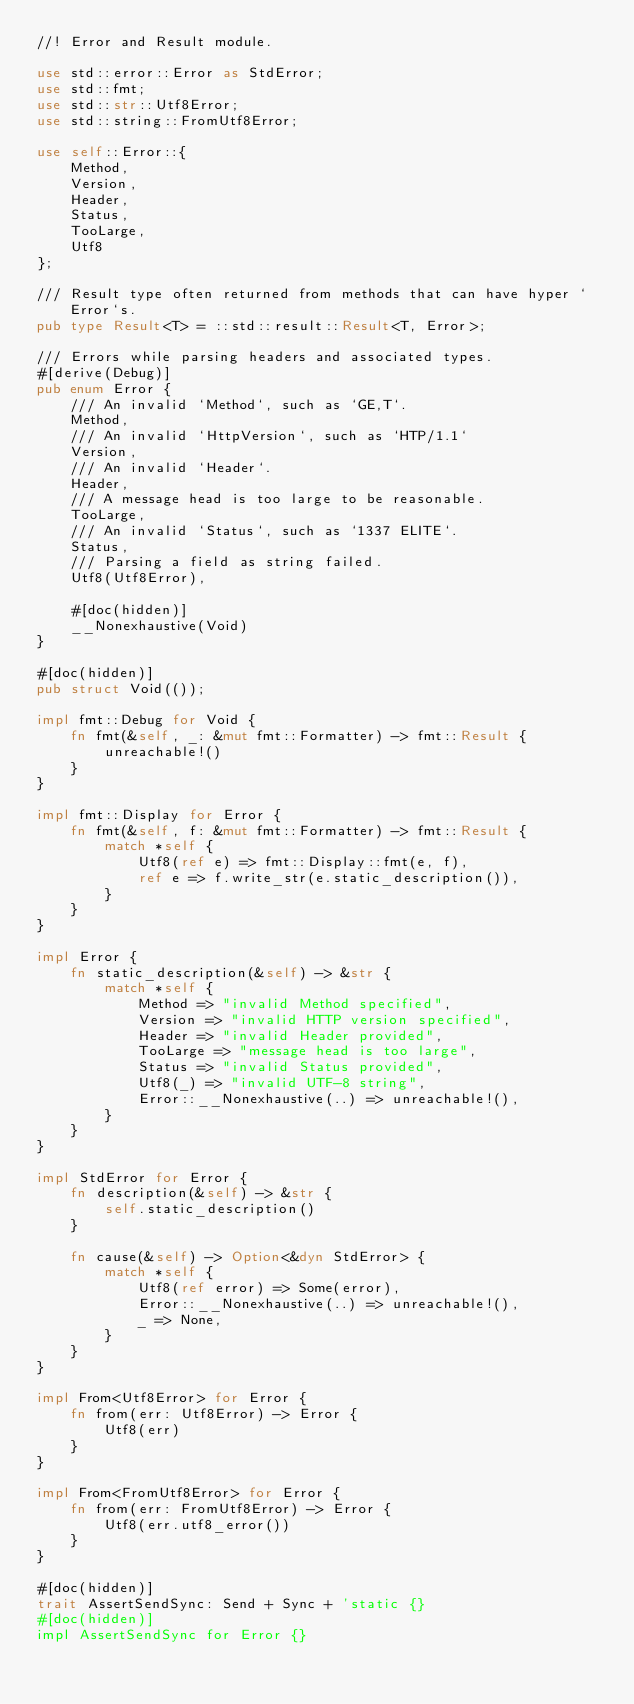Convert code to text. <code><loc_0><loc_0><loc_500><loc_500><_Rust_>//! Error and Result module.

use std::error::Error as StdError;
use std::fmt;
use std::str::Utf8Error;
use std::string::FromUtf8Error;

use self::Error::{
    Method,
    Version,
    Header,
    Status,
    TooLarge,
    Utf8
};

/// Result type often returned from methods that can have hyper `Error`s.
pub type Result<T> = ::std::result::Result<T, Error>;

/// Errors while parsing headers and associated types.
#[derive(Debug)]
pub enum Error {
    /// An invalid `Method`, such as `GE,T`.
    Method,
    /// An invalid `HttpVersion`, such as `HTP/1.1`
    Version,
    /// An invalid `Header`.
    Header,
    /// A message head is too large to be reasonable.
    TooLarge,
    /// An invalid `Status`, such as `1337 ELITE`.
    Status,
    /// Parsing a field as string failed.
    Utf8(Utf8Error),

    #[doc(hidden)]
    __Nonexhaustive(Void)
}

#[doc(hidden)]
pub struct Void(());

impl fmt::Debug for Void {
    fn fmt(&self, _: &mut fmt::Formatter) -> fmt::Result {
        unreachable!()
    }
}

impl fmt::Display for Error {
    fn fmt(&self, f: &mut fmt::Formatter) -> fmt::Result {
        match *self {
            Utf8(ref e) => fmt::Display::fmt(e, f),
            ref e => f.write_str(e.static_description()),
        }
    }
}

impl Error {
    fn static_description(&self) -> &str {
        match *self {
            Method => "invalid Method specified",
            Version => "invalid HTTP version specified",
            Header => "invalid Header provided",
            TooLarge => "message head is too large",
            Status => "invalid Status provided",
            Utf8(_) => "invalid UTF-8 string",
            Error::__Nonexhaustive(..) => unreachable!(),
        }
    }
}

impl StdError for Error {
    fn description(&self) -> &str {
        self.static_description()
    }

    fn cause(&self) -> Option<&dyn StdError> {
        match *self {
            Utf8(ref error) => Some(error),
            Error::__Nonexhaustive(..) => unreachable!(),
            _ => None,
        }
    }
}

impl From<Utf8Error> for Error {
    fn from(err: Utf8Error) -> Error {
        Utf8(err)
    }
}

impl From<FromUtf8Error> for Error {
    fn from(err: FromUtf8Error) -> Error {
        Utf8(err.utf8_error())
    }
}

#[doc(hidden)]
trait AssertSendSync: Send + Sync + 'static {}
#[doc(hidden)]
impl AssertSendSync for Error {}
</code> 